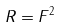<formula> <loc_0><loc_0><loc_500><loc_500>R = F ^ { 2 }</formula> 